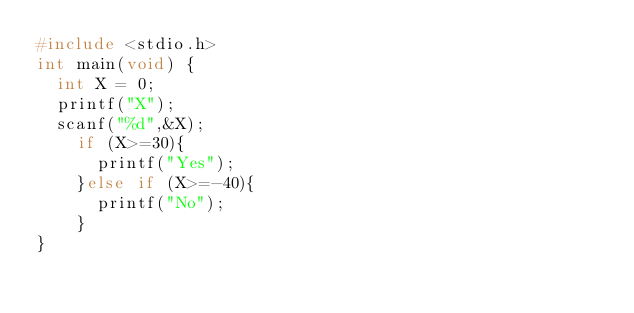<code> <loc_0><loc_0><loc_500><loc_500><_C_>#include <stdio.h>
int main(void) {
	int X = 0; 
	printf("X");
	scanf("%d",&X);
  	if (X>=30){
      printf("Yes");
    }else if (X>=-40){
      printf("No");
    }
}</code> 